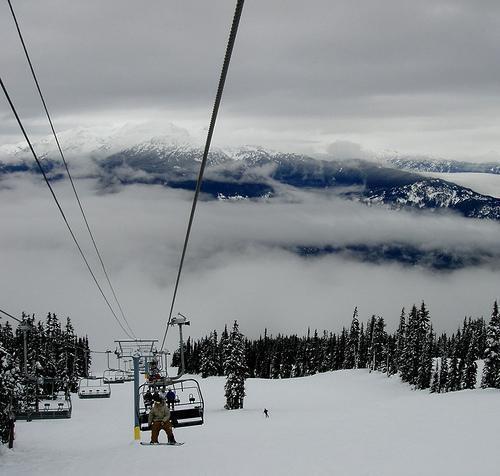Where does the carrier take the man to?
Choose the correct response and explain in the format: 'Answer: answer
Rationale: rationale.'
Options: Right, uphill, downhill, left. Answer: uphill.
Rationale: It makes it easier to go up a mountain quickly 